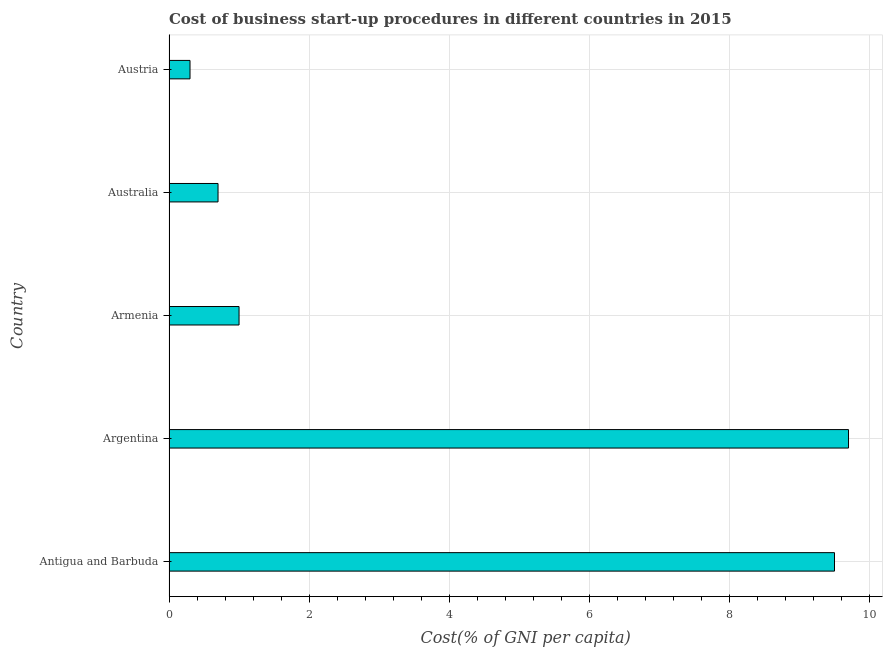Does the graph contain any zero values?
Provide a short and direct response. No. Does the graph contain grids?
Provide a succinct answer. Yes. What is the title of the graph?
Make the answer very short. Cost of business start-up procedures in different countries in 2015. What is the label or title of the X-axis?
Offer a terse response. Cost(% of GNI per capita). What is the cost of business startup procedures in Austria?
Keep it short and to the point. 0.3. Across all countries, what is the minimum cost of business startup procedures?
Offer a very short reply. 0.3. In which country was the cost of business startup procedures maximum?
Provide a succinct answer. Argentina. What is the sum of the cost of business startup procedures?
Keep it short and to the point. 21.2. What is the average cost of business startup procedures per country?
Your response must be concise. 4.24. In how many countries, is the cost of business startup procedures greater than 5.2 %?
Ensure brevity in your answer.  2. What is the ratio of the cost of business startup procedures in Antigua and Barbuda to that in Armenia?
Offer a very short reply. 9.5. Is the difference between the cost of business startup procedures in Argentina and Armenia greater than the difference between any two countries?
Offer a terse response. No. How many countries are there in the graph?
Give a very brief answer. 5. What is the difference between two consecutive major ticks on the X-axis?
Your answer should be compact. 2. What is the Cost(% of GNI per capita) in Argentina?
Your answer should be very brief. 9.7. What is the Cost(% of GNI per capita) of Armenia?
Your answer should be very brief. 1. What is the Cost(% of GNI per capita) of Australia?
Give a very brief answer. 0.7. What is the difference between the Cost(% of GNI per capita) in Antigua and Barbuda and Argentina?
Your answer should be very brief. -0.2. What is the difference between the Cost(% of GNI per capita) in Antigua and Barbuda and Armenia?
Ensure brevity in your answer.  8.5. What is the difference between the Cost(% of GNI per capita) in Antigua and Barbuda and Australia?
Provide a succinct answer. 8.8. What is the difference between the Cost(% of GNI per capita) in Antigua and Barbuda and Austria?
Offer a very short reply. 9.2. What is the difference between the Cost(% of GNI per capita) in Argentina and Armenia?
Make the answer very short. 8.7. What is the difference between the Cost(% of GNI per capita) in Argentina and Australia?
Provide a short and direct response. 9. What is the difference between the Cost(% of GNI per capita) in Armenia and Austria?
Give a very brief answer. 0.7. What is the ratio of the Cost(% of GNI per capita) in Antigua and Barbuda to that in Armenia?
Offer a very short reply. 9.5. What is the ratio of the Cost(% of GNI per capita) in Antigua and Barbuda to that in Australia?
Keep it short and to the point. 13.57. What is the ratio of the Cost(% of GNI per capita) in Antigua and Barbuda to that in Austria?
Make the answer very short. 31.67. What is the ratio of the Cost(% of GNI per capita) in Argentina to that in Armenia?
Your response must be concise. 9.7. What is the ratio of the Cost(% of GNI per capita) in Argentina to that in Australia?
Offer a terse response. 13.86. What is the ratio of the Cost(% of GNI per capita) in Argentina to that in Austria?
Offer a very short reply. 32.33. What is the ratio of the Cost(% of GNI per capita) in Armenia to that in Australia?
Give a very brief answer. 1.43. What is the ratio of the Cost(% of GNI per capita) in Armenia to that in Austria?
Make the answer very short. 3.33. What is the ratio of the Cost(% of GNI per capita) in Australia to that in Austria?
Give a very brief answer. 2.33. 